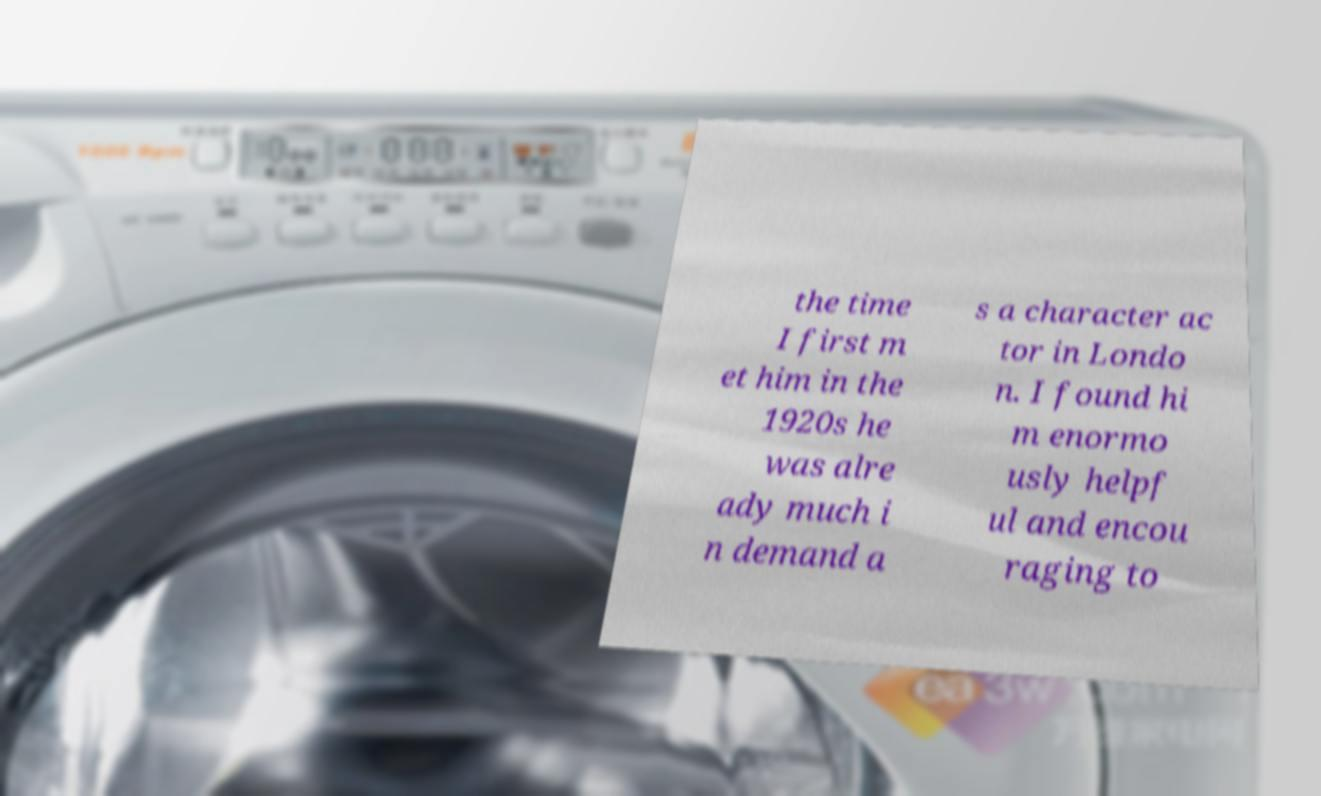Could you assist in decoding the text presented in this image and type it out clearly? the time I first m et him in the 1920s he was alre ady much i n demand a s a character ac tor in Londo n. I found hi m enormo usly helpf ul and encou raging to 